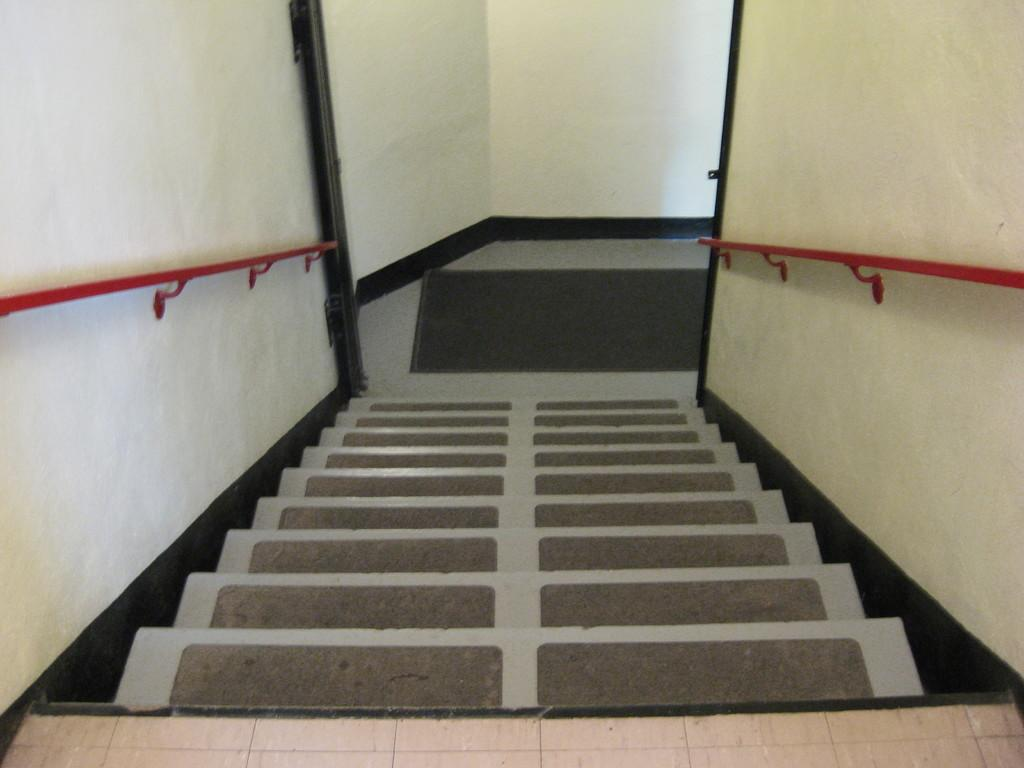What is located in the middle of the image? There are steps in the middle of the image. What is placed on the steps? Mats are placed on the steps. What type of material are the rods on either side of the steps made of? The rods are made of iron. What can be seen at the top of the steps? There is a wall at the top of the steps. What is on the floor near the steps? There is a mat on the floor. Where is the quicksand located in the image? There is no quicksand present in the image. How many chairs are visible in the image? There are no chairs visible in the image. 